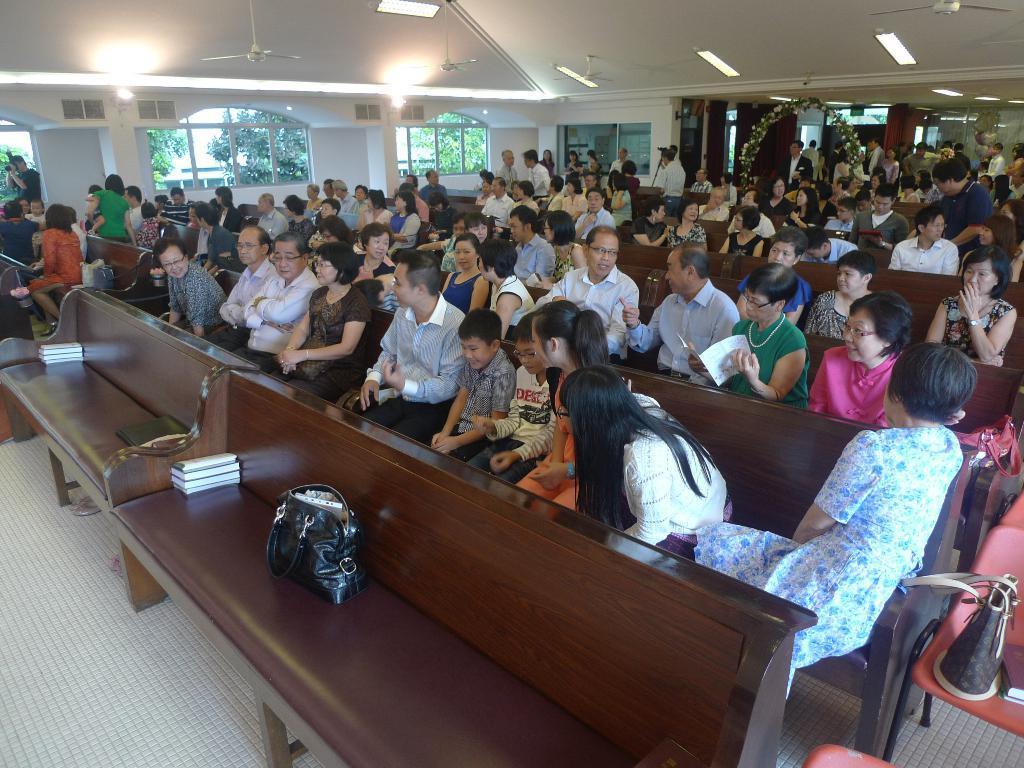Describe this image in one or two sentences. In this image we can see group of people sitting on benches. In the foreground of the image we can see a bag placed on a bench. In the back ground we can see some people standing and group of fans windows and trees. 